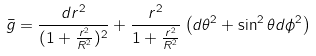<formula> <loc_0><loc_0><loc_500><loc_500>\bar { g } = \frac { d r ^ { 2 } } { ( 1 + \frac { r ^ { 2 } } { R ^ { 2 } } ) ^ { 2 } } + \frac { r ^ { 2 } } { 1 + \frac { r ^ { 2 } } { R ^ { 2 } } } \left ( d \theta ^ { 2 } + \sin ^ { 2 } \theta d \phi ^ { 2 } \right )</formula> 